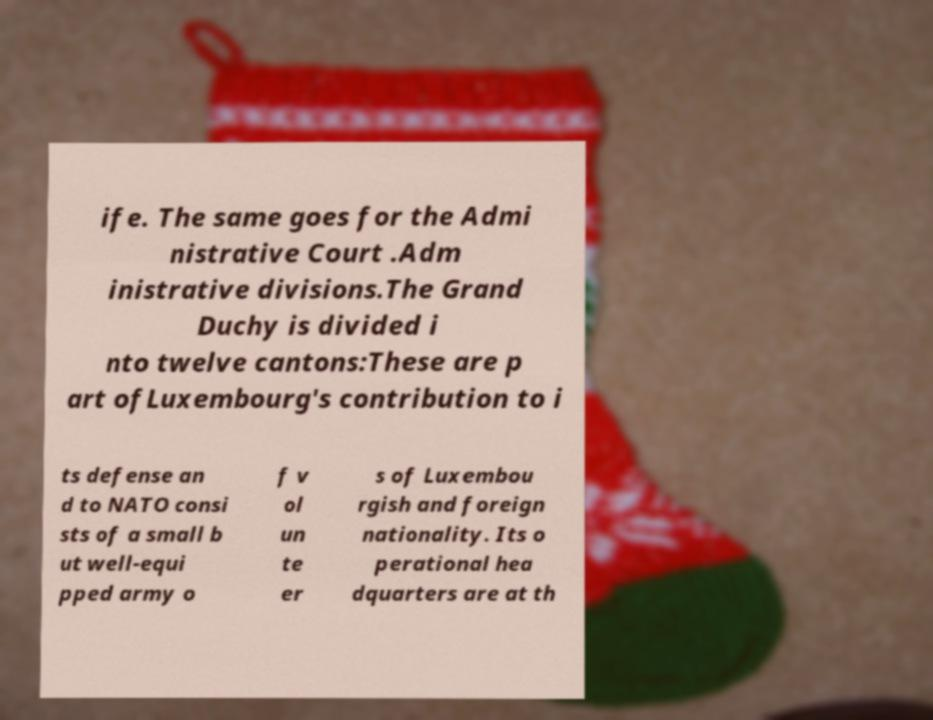Can you read and provide the text displayed in the image?This photo seems to have some interesting text. Can you extract and type it out for me? ife. The same goes for the Admi nistrative Court .Adm inistrative divisions.The Grand Duchy is divided i nto twelve cantons:These are p art ofLuxembourg's contribution to i ts defense an d to NATO consi sts of a small b ut well-equi pped army o f v ol un te er s of Luxembou rgish and foreign nationality. Its o perational hea dquarters are at th 